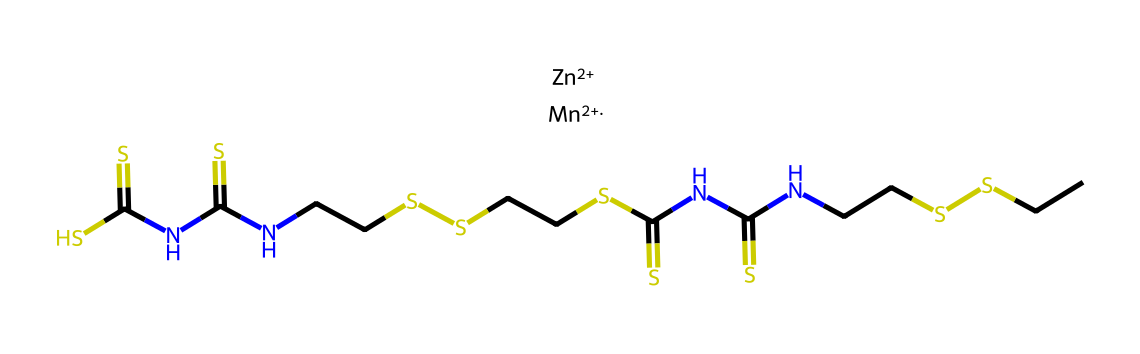What is the full name of this chemical? The SMILES representation indicates the presence of zinc and manganese alongside sulfur and carbon chains, suggesting the chemical's name is mancozeb.
Answer: mancozeb How many sulfur atoms are present in this chemical? By counting the "S" symbols in the SMILES representation, there are four sulfur atoms indicated in the structure.
Answer: four What role do zinc and manganese play in the structure? Zinc and manganese contribute to the fungicidal properties of the compound; their presence stabilizes the structure and enhances its biological activity against fungi.
Answer: fungicides How many carbon atoms are there in the chemical? Counting the "C" symbols in the SMILES notation reveals a total of 14 carbon atoms in the structure.
Answer: fourteen What type of chemical bonding is primarily observed in this compound? The structure indicates the presence of covalent bonds formed between carbon, sulfur, nitrogen, zinc, and manganese, characteristic of organometallic structures.
Answer: covalent What functional groups are identified in this fungicide? The chemical structure includes thiourea groups (–N(C(S)S)–) which are vital for its fungicidal action, suggesting that these groups enhance its reactivity toward fungal pathogens.
Answer: thiourea Is this compound primarily used for agricultural purposes or industrial applications? Mancozeb is primarily utilized in agriculture as a protective fungicide, indicating its agricultural applications rather than industrial ones.
Answer: agricultural 